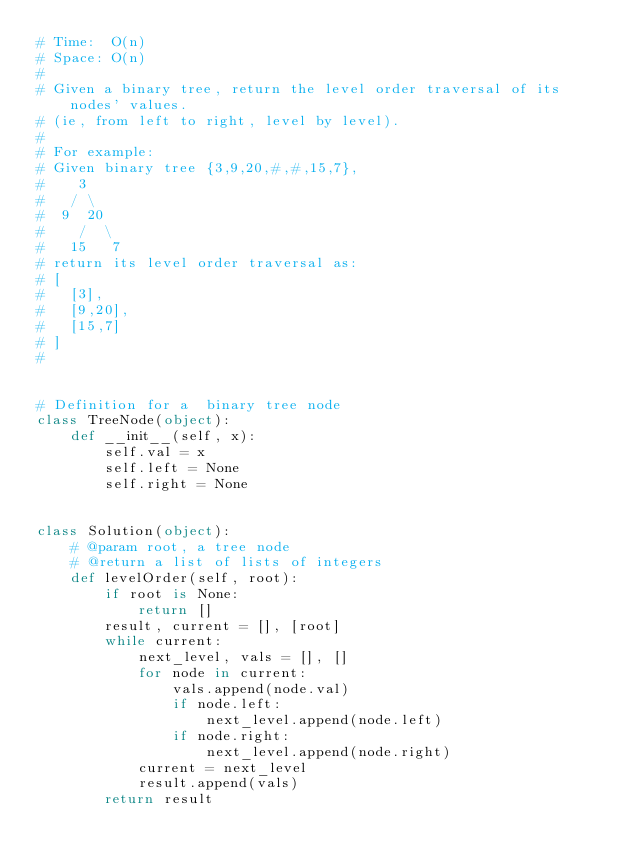Convert code to text. <code><loc_0><loc_0><loc_500><loc_500><_Python_># Time:  O(n)
# Space: O(n)
#
# Given a binary tree, return the level order traversal of its nodes' values.
# (ie, from left to right, level by level).
#
# For example:
# Given binary tree {3,9,20,#,#,15,7},
#    3
#   / \
#  9  20
#    /  \
#   15   7
# return its level order traversal as:
# [
#   [3],
#   [9,20],
#   [15,7]
# ]
#


# Definition for a  binary tree node
class TreeNode(object):
    def __init__(self, x):
        self.val = x
        self.left = None
        self.right = None


class Solution(object):
    # @param root, a tree node
    # @return a list of lists of integers
    def levelOrder(self, root):
        if root is None:
            return []
        result, current = [], [root]
        while current:
            next_level, vals = [], []
            for node in current:
                vals.append(node.val)
                if node.left:
                    next_level.append(node.left)
                if node.right:
                    next_level.append(node.right)
            current = next_level
            result.append(vals)
        return result
</code> 